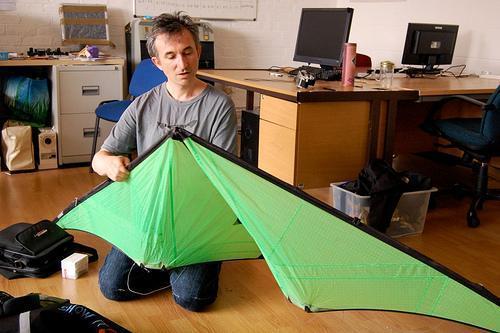How many green kites does the man have?
Give a very brief answer. 1. 